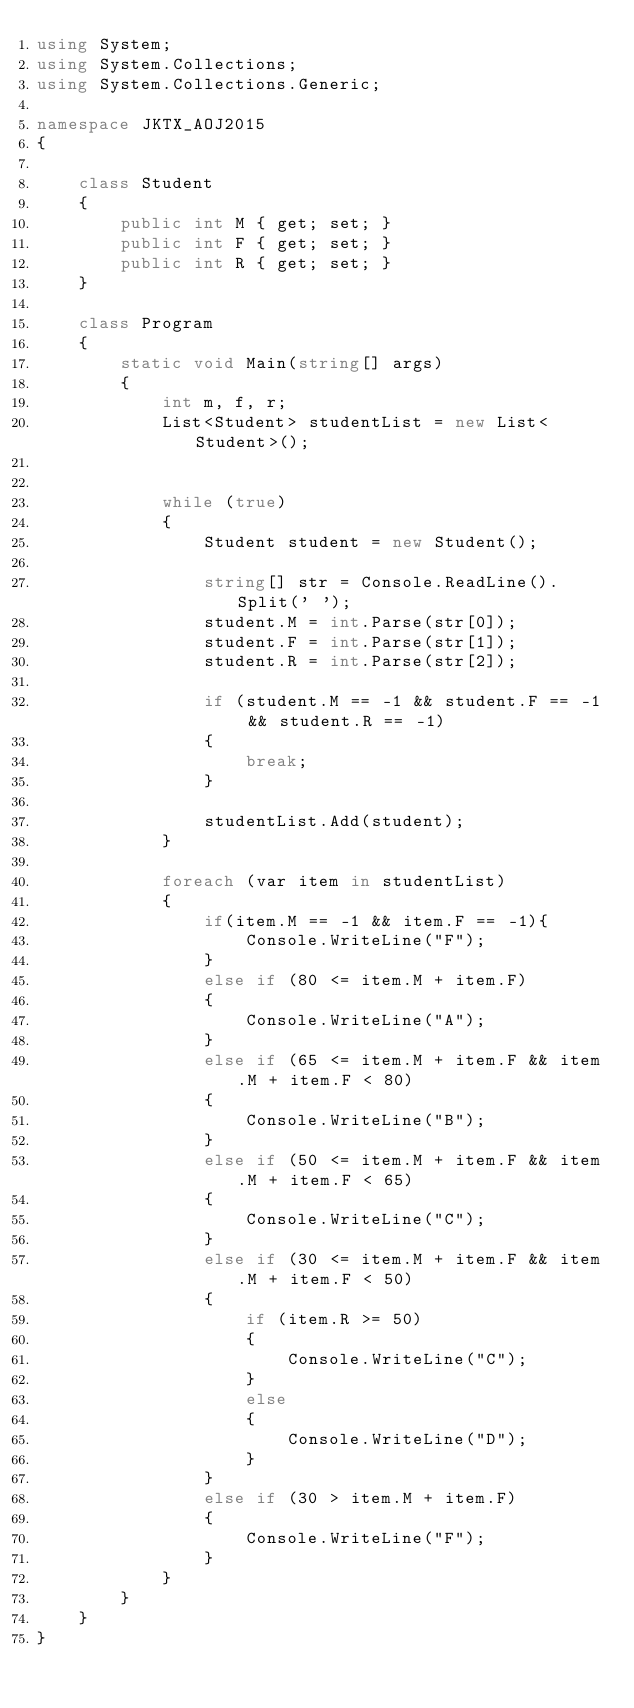Convert code to text. <code><loc_0><loc_0><loc_500><loc_500><_C#_>using System;
using System.Collections;
using System.Collections.Generic;

namespace JKTX_AOJ2015
{

    class Student
    {
        public int M { get; set; }
        public int F { get; set; }
        public int R { get; set; }
    }

    class Program
    {
        static void Main(string[] args)
        {
            int m, f, r;
            List<Student> studentList = new List<Student>();


            while (true)
            {
                Student student = new Student();

                string[] str = Console.ReadLine().Split(' ');
                student.M = int.Parse(str[0]);
                student.F = int.Parse(str[1]);
                student.R = int.Parse(str[2]);

                if (student.M == -1 && student.F == -1 && student.R == -1)
                {
                    break;
                }

                studentList.Add(student);
            }

            foreach (var item in studentList)
            {
                if(item.M == -1 && item.F == -1){
                    Console.WriteLine("F");
                }
                else if (80 <= item.M + item.F)
                {
                    Console.WriteLine("A");
                }
                else if (65 <= item.M + item.F && item.M + item.F < 80)
                {
                    Console.WriteLine("B");
                }
                else if (50 <= item.M + item.F && item.M + item.F < 65)
                {
                    Console.WriteLine("C");
                }
                else if (30 <= item.M + item.F && item.M + item.F < 50)
                {
                    if (item.R >= 50)
                    {
                        Console.WriteLine("C");
                    }
                    else
                    {
                        Console.WriteLine("D");
                    }
                }
                else if (30 > item.M + item.F)
                {
                    Console.WriteLine("F");
                }
            }
        }
    }
}</code> 